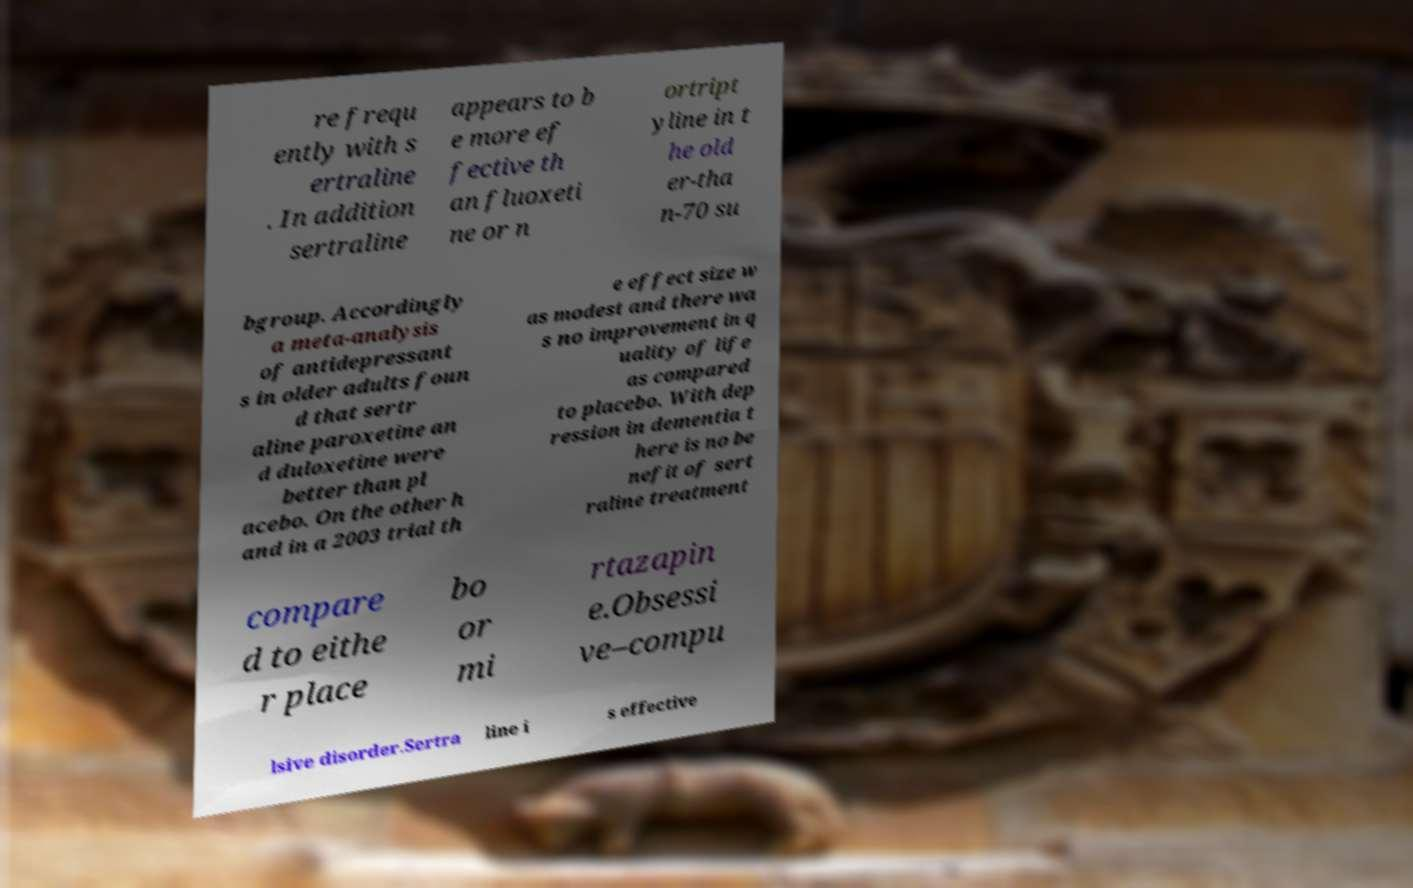I need the written content from this picture converted into text. Can you do that? re frequ ently with s ertraline . In addition sertraline appears to b e more ef fective th an fluoxeti ne or n ortript yline in t he old er-tha n-70 su bgroup. Accordingly a meta-analysis of antidepressant s in older adults foun d that sertr aline paroxetine an d duloxetine were better than pl acebo. On the other h and in a 2003 trial th e effect size w as modest and there wa s no improvement in q uality of life as compared to placebo. With dep ression in dementia t here is no be nefit of sert raline treatment compare d to eithe r place bo or mi rtazapin e.Obsessi ve–compu lsive disorder.Sertra line i s effective 